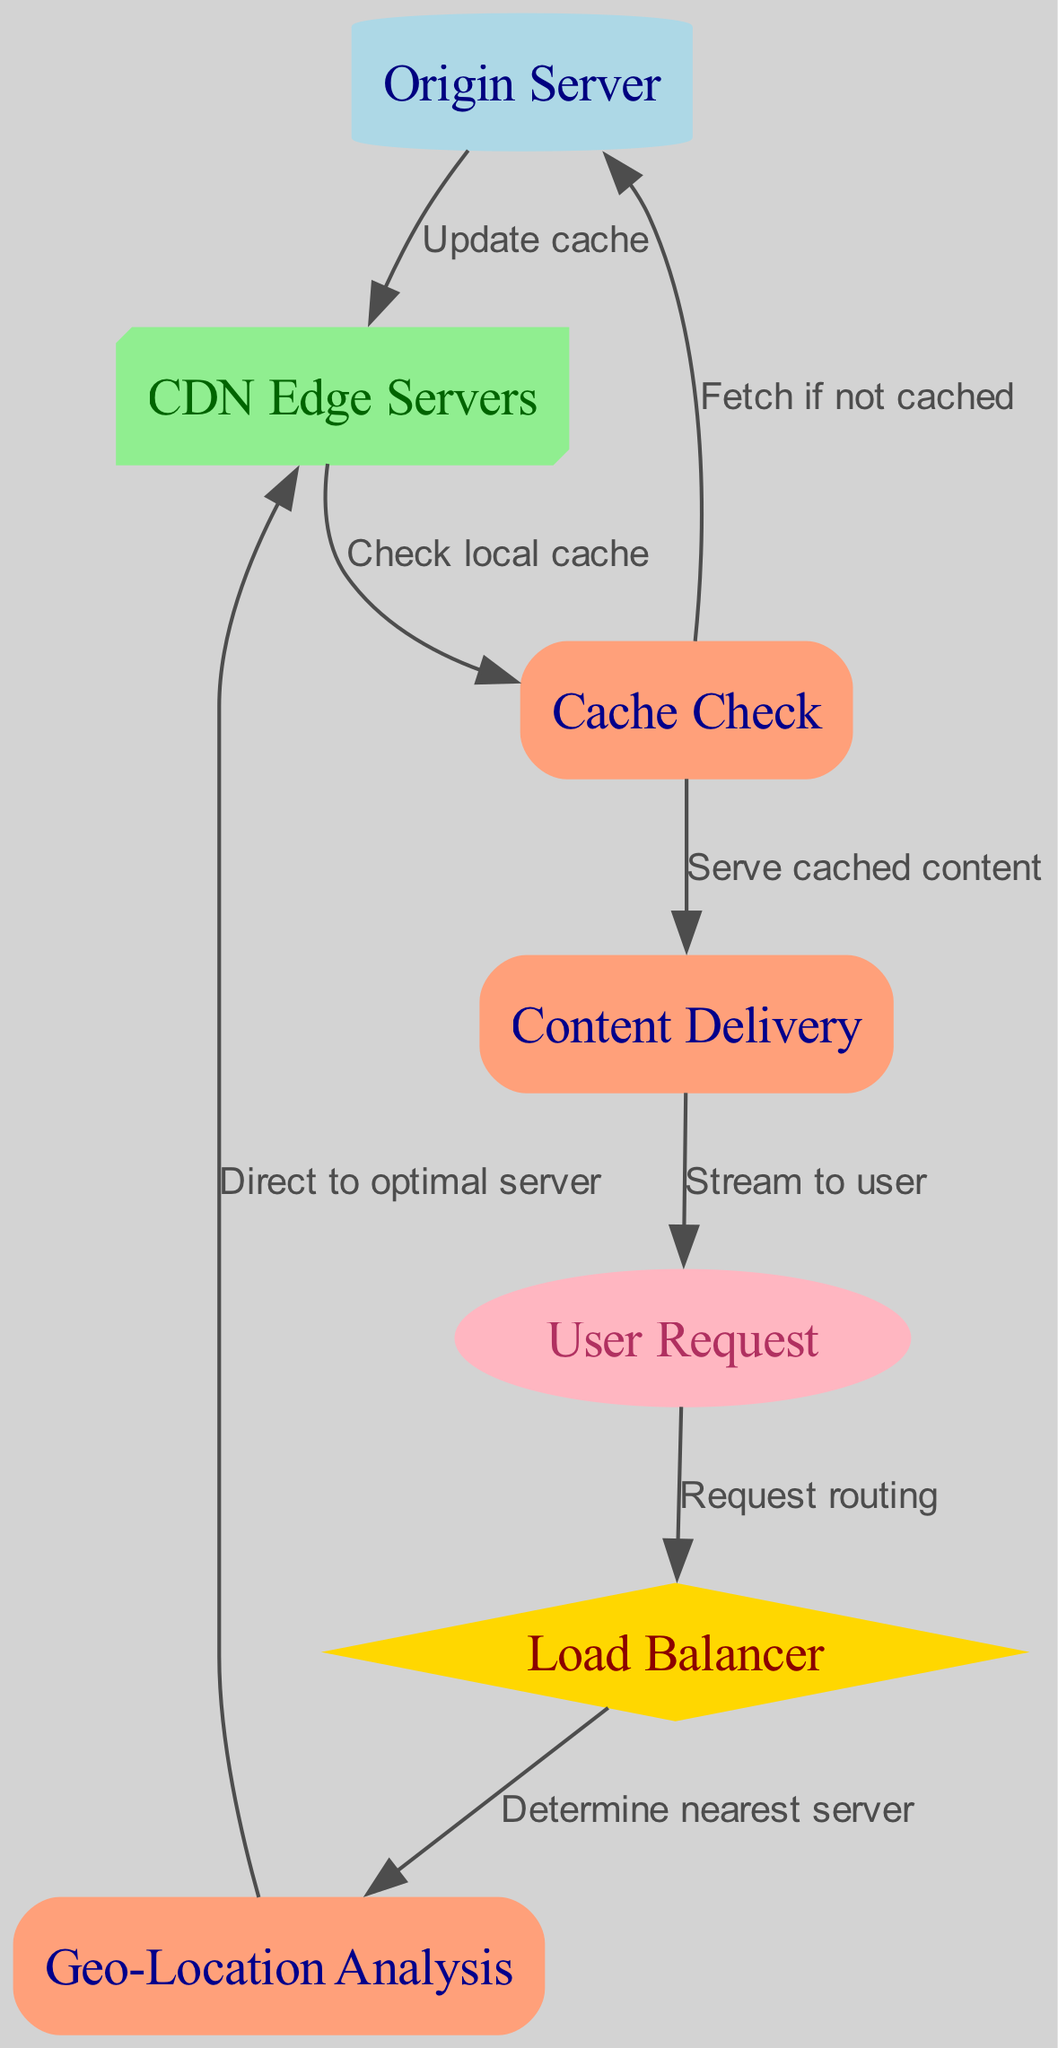What is the starting point of the flowchart? The starting point of the flowchart is the "User Request" node, which is where the process initiates when a user requests content. This is indicated by node ID 4 in the diagram.
Answer: User Request How many nodes are present in the diagram? There are a total of 7 nodes in the diagram, identified by their respective IDs. This includes the Origin Server, CDN Edge Servers, Load Balancer, User Request, Geo-Location Analysis, Cache Check, and Content Delivery.
Answer: 7 What action follows the "Cache Check" node if the content is cached? If the content is cached, the next action following the "Cache Check" node is to "Serve cached content," which is indicated by the edge leading to the Content Delivery node.
Answer: Serve cached content What directs the request to the optimal server? The "Geo-Location Analysis" node directs the request to the optimal server, as indicated by the edge that connects it to the "CDN Edge Servers" node in the flowchart.
Answer: Direct to optimal server What does the "Origin Server" do if the content is not cached? If the content is not cached, the "Origin Server" fetches the required content to update the cache, as indicated by the edge from the "Cache Check" node to the "Origin Server."
Answer: Fetch if not cached What type of server is represented by node ID 2? Node ID 2 represents the "CDN Edge Servers," which are essential in the content delivery process to serve users from the closest location.
Answer: CDN Edge Servers What process is illustrated between the "Load Balancer" and "Geo-Location Analysis"? The process illustrated between the "Load Balancer" and "Geo-Location Analysis" is "Determine nearest server," showing that the load balancer decides which server to use based on the user's location.
Answer: Determine nearest server How does content flow from the CDN to the user? Content flows from the CDN to the user through the action "Stream to user," which is the connection from the "Content Delivery" node back to the initial "User Request" node.
Answer: Stream to user 